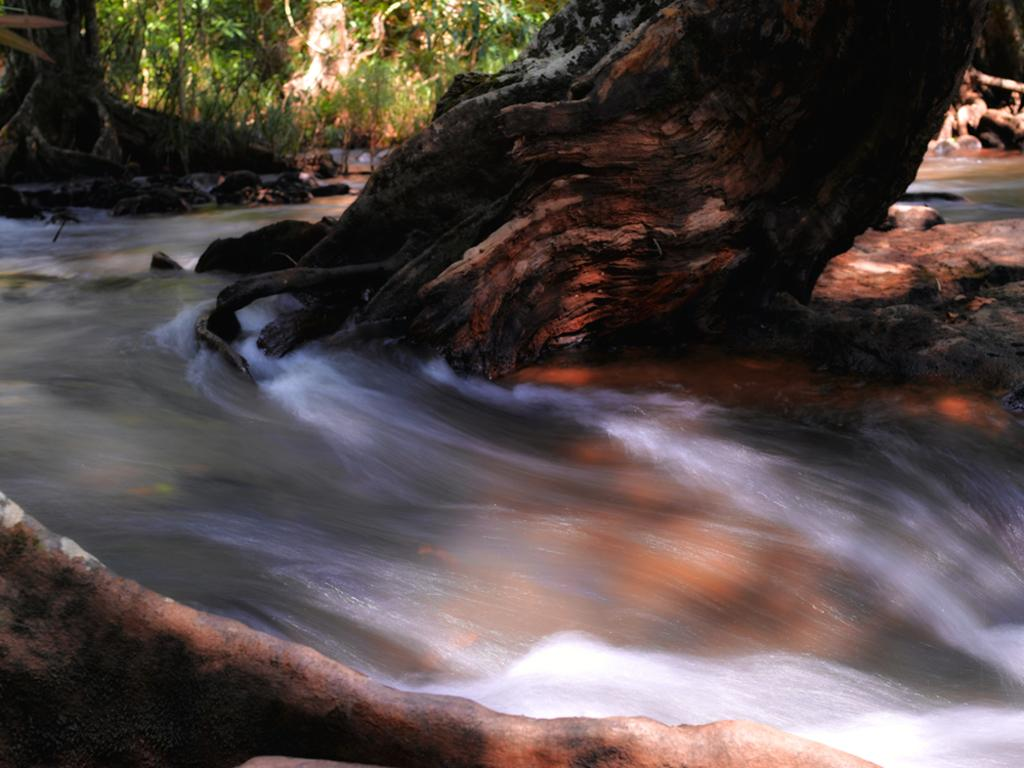What is visible in the image? There is water visible in the image. What can be seen in the background of the image? There are many trees in the background of the image. What type of faucet is used to control the water in the image? There is no faucet present in the image; the water is not controlled by a faucet. What thoughts or ideas are being expressed by the water in the image? The water in the image does not express any thoughts or ideas, as it is an inanimate object. 